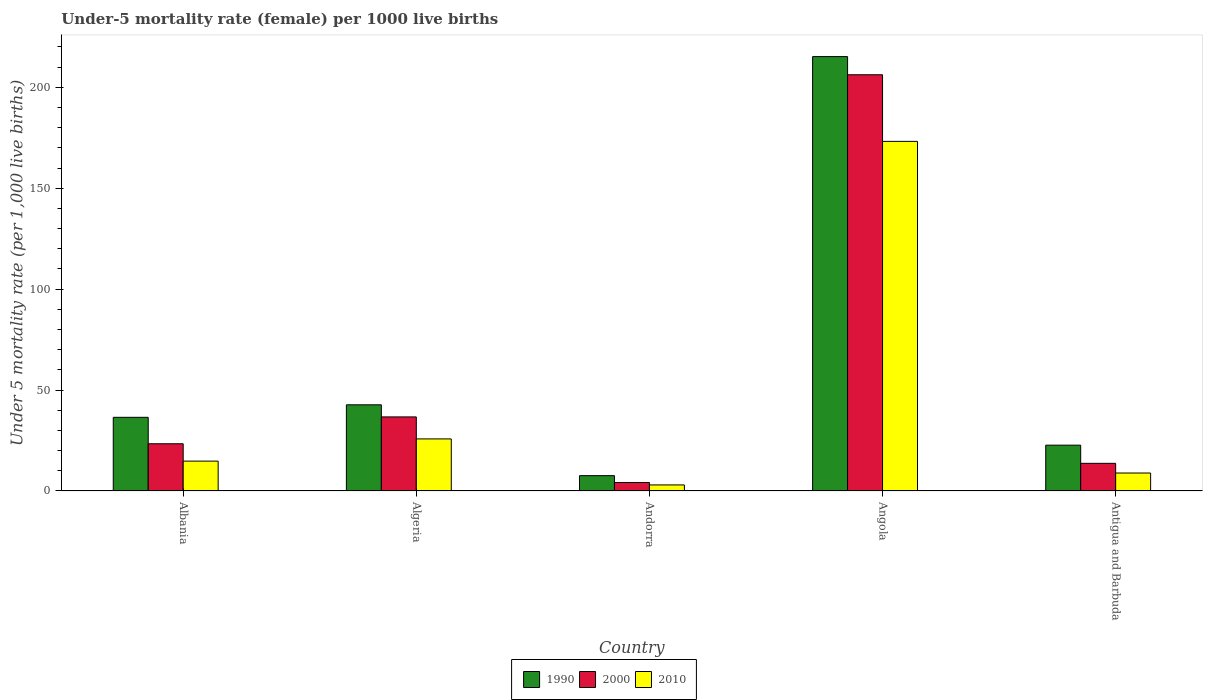How many different coloured bars are there?
Your response must be concise. 3. Are the number of bars on each tick of the X-axis equal?
Make the answer very short. Yes. What is the label of the 3rd group of bars from the left?
Offer a terse response. Andorra. In how many cases, is the number of bars for a given country not equal to the number of legend labels?
Offer a terse response. 0. What is the under-five mortality rate in 1990 in Angola?
Give a very brief answer. 215.2. Across all countries, what is the maximum under-five mortality rate in 2000?
Your answer should be compact. 206.2. In which country was the under-five mortality rate in 2000 maximum?
Provide a short and direct response. Angola. In which country was the under-five mortality rate in 2000 minimum?
Give a very brief answer. Andorra. What is the total under-five mortality rate in 1990 in the graph?
Your response must be concise. 324.7. What is the difference between the under-five mortality rate in 2010 in Algeria and that in Angola?
Make the answer very short. -147.4. What is the difference between the under-five mortality rate in 2000 in Antigua and Barbuda and the under-five mortality rate in 2010 in Albania?
Keep it short and to the point. -1.1. What is the average under-five mortality rate in 1990 per country?
Provide a succinct answer. 64.94. What is the difference between the under-five mortality rate of/in 2010 and under-five mortality rate of/in 1990 in Andorra?
Your answer should be compact. -4.6. In how many countries, is the under-five mortality rate in 2000 greater than 40?
Offer a very short reply. 1. What is the ratio of the under-five mortality rate in 2010 in Albania to that in Angola?
Give a very brief answer. 0.09. What is the difference between the highest and the second highest under-five mortality rate in 2000?
Ensure brevity in your answer.  -169.5. What is the difference between the highest and the lowest under-five mortality rate in 2010?
Your answer should be compact. 170.2. Is the sum of the under-five mortality rate in 2010 in Algeria and Antigua and Barbuda greater than the maximum under-five mortality rate in 2000 across all countries?
Ensure brevity in your answer.  No. What does the 3rd bar from the left in Angola represents?
Your answer should be very brief. 2010. Is it the case that in every country, the sum of the under-five mortality rate in 2010 and under-five mortality rate in 1990 is greater than the under-five mortality rate in 2000?
Your answer should be compact. Yes. How many bars are there?
Offer a very short reply. 15. Are all the bars in the graph horizontal?
Your answer should be very brief. No. Are the values on the major ticks of Y-axis written in scientific E-notation?
Provide a short and direct response. No. Does the graph contain grids?
Make the answer very short. No. Where does the legend appear in the graph?
Offer a terse response. Bottom center. How many legend labels are there?
Provide a short and direct response. 3. How are the legend labels stacked?
Offer a terse response. Horizontal. What is the title of the graph?
Provide a short and direct response. Under-5 mortality rate (female) per 1000 live births. What is the label or title of the Y-axis?
Offer a terse response. Under 5 mortality rate (per 1,0 live births). What is the Under 5 mortality rate (per 1,000 live births) of 1990 in Albania?
Your answer should be compact. 36.5. What is the Under 5 mortality rate (per 1,000 live births) in 2000 in Albania?
Make the answer very short. 23.4. What is the Under 5 mortality rate (per 1,000 live births) of 1990 in Algeria?
Give a very brief answer. 42.7. What is the Under 5 mortality rate (per 1,000 live births) in 2000 in Algeria?
Make the answer very short. 36.7. What is the Under 5 mortality rate (per 1,000 live births) in 2010 in Algeria?
Keep it short and to the point. 25.8. What is the Under 5 mortality rate (per 1,000 live births) in 1990 in Andorra?
Offer a very short reply. 7.6. What is the Under 5 mortality rate (per 1,000 live births) of 2000 in Andorra?
Provide a short and direct response. 4.2. What is the Under 5 mortality rate (per 1,000 live births) in 2010 in Andorra?
Keep it short and to the point. 3. What is the Under 5 mortality rate (per 1,000 live births) of 1990 in Angola?
Give a very brief answer. 215.2. What is the Under 5 mortality rate (per 1,000 live births) in 2000 in Angola?
Your response must be concise. 206.2. What is the Under 5 mortality rate (per 1,000 live births) of 2010 in Angola?
Your response must be concise. 173.2. What is the Under 5 mortality rate (per 1,000 live births) in 1990 in Antigua and Barbuda?
Provide a short and direct response. 22.7. Across all countries, what is the maximum Under 5 mortality rate (per 1,000 live births) in 1990?
Your answer should be very brief. 215.2. Across all countries, what is the maximum Under 5 mortality rate (per 1,000 live births) in 2000?
Ensure brevity in your answer.  206.2. Across all countries, what is the maximum Under 5 mortality rate (per 1,000 live births) of 2010?
Give a very brief answer. 173.2. Across all countries, what is the minimum Under 5 mortality rate (per 1,000 live births) in 1990?
Provide a succinct answer. 7.6. What is the total Under 5 mortality rate (per 1,000 live births) in 1990 in the graph?
Your answer should be very brief. 324.7. What is the total Under 5 mortality rate (per 1,000 live births) in 2000 in the graph?
Your answer should be very brief. 284.2. What is the total Under 5 mortality rate (per 1,000 live births) of 2010 in the graph?
Your response must be concise. 225.7. What is the difference between the Under 5 mortality rate (per 1,000 live births) in 1990 in Albania and that in Algeria?
Keep it short and to the point. -6.2. What is the difference between the Under 5 mortality rate (per 1,000 live births) of 1990 in Albania and that in Andorra?
Offer a very short reply. 28.9. What is the difference between the Under 5 mortality rate (per 1,000 live births) of 2000 in Albania and that in Andorra?
Provide a succinct answer. 19.2. What is the difference between the Under 5 mortality rate (per 1,000 live births) of 1990 in Albania and that in Angola?
Your answer should be very brief. -178.7. What is the difference between the Under 5 mortality rate (per 1,000 live births) in 2000 in Albania and that in Angola?
Give a very brief answer. -182.8. What is the difference between the Under 5 mortality rate (per 1,000 live births) of 2010 in Albania and that in Angola?
Ensure brevity in your answer.  -158.4. What is the difference between the Under 5 mortality rate (per 1,000 live births) of 1990 in Albania and that in Antigua and Barbuda?
Give a very brief answer. 13.8. What is the difference between the Under 5 mortality rate (per 1,000 live births) of 2000 in Albania and that in Antigua and Barbuda?
Ensure brevity in your answer.  9.7. What is the difference between the Under 5 mortality rate (per 1,000 live births) of 2010 in Albania and that in Antigua and Barbuda?
Give a very brief answer. 5.9. What is the difference between the Under 5 mortality rate (per 1,000 live births) in 1990 in Algeria and that in Andorra?
Offer a terse response. 35.1. What is the difference between the Under 5 mortality rate (per 1,000 live births) of 2000 in Algeria and that in Andorra?
Ensure brevity in your answer.  32.5. What is the difference between the Under 5 mortality rate (per 1,000 live births) in 2010 in Algeria and that in Andorra?
Keep it short and to the point. 22.8. What is the difference between the Under 5 mortality rate (per 1,000 live births) of 1990 in Algeria and that in Angola?
Make the answer very short. -172.5. What is the difference between the Under 5 mortality rate (per 1,000 live births) of 2000 in Algeria and that in Angola?
Your answer should be very brief. -169.5. What is the difference between the Under 5 mortality rate (per 1,000 live births) of 2010 in Algeria and that in Angola?
Provide a short and direct response. -147.4. What is the difference between the Under 5 mortality rate (per 1,000 live births) of 1990 in Algeria and that in Antigua and Barbuda?
Your answer should be compact. 20. What is the difference between the Under 5 mortality rate (per 1,000 live births) in 2000 in Algeria and that in Antigua and Barbuda?
Your answer should be compact. 23. What is the difference between the Under 5 mortality rate (per 1,000 live births) in 2010 in Algeria and that in Antigua and Barbuda?
Offer a terse response. 16.9. What is the difference between the Under 5 mortality rate (per 1,000 live births) in 1990 in Andorra and that in Angola?
Your answer should be compact. -207.6. What is the difference between the Under 5 mortality rate (per 1,000 live births) in 2000 in Andorra and that in Angola?
Ensure brevity in your answer.  -202. What is the difference between the Under 5 mortality rate (per 1,000 live births) in 2010 in Andorra and that in Angola?
Your response must be concise. -170.2. What is the difference between the Under 5 mortality rate (per 1,000 live births) of 1990 in Andorra and that in Antigua and Barbuda?
Make the answer very short. -15.1. What is the difference between the Under 5 mortality rate (per 1,000 live births) of 1990 in Angola and that in Antigua and Barbuda?
Provide a short and direct response. 192.5. What is the difference between the Under 5 mortality rate (per 1,000 live births) of 2000 in Angola and that in Antigua and Barbuda?
Offer a terse response. 192.5. What is the difference between the Under 5 mortality rate (per 1,000 live births) in 2010 in Angola and that in Antigua and Barbuda?
Keep it short and to the point. 164.3. What is the difference between the Under 5 mortality rate (per 1,000 live births) of 1990 in Albania and the Under 5 mortality rate (per 1,000 live births) of 2000 in Algeria?
Keep it short and to the point. -0.2. What is the difference between the Under 5 mortality rate (per 1,000 live births) in 2000 in Albania and the Under 5 mortality rate (per 1,000 live births) in 2010 in Algeria?
Provide a short and direct response. -2.4. What is the difference between the Under 5 mortality rate (per 1,000 live births) in 1990 in Albania and the Under 5 mortality rate (per 1,000 live births) in 2000 in Andorra?
Keep it short and to the point. 32.3. What is the difference between the Under 5 mortality rate (per 1,000 live births) in 1990 in Albania and the Under 5 mortality rate (per 1,000 live births) in 2010 in Andorra?
Make the answer very short. 33.5. What is the difference between the Under 5 mortality rate (per 1,000 live births) in 2000 in Albania and the Under 5 mortality rate (per 1,000 live births) in 2010 in Andorra?
Keep it short and to the point. 20.4. What is the difference between the Under 5 mortality rate (per 1,000 live births) in 1990 in Albania and the Under 5 mortality rate (per 1,000 live births) in 2000 in Angola?
Make the answer very short. -169.7. What is the difference between the Under 5 mortality rate (per 1,000 live births) in 1990 in Albania and the Under 5 mortality rate (per 1,000 live births) in 2010 in Angola?
Your answer should be compact. -136.7. What is the difference between the Under 5 mortality rate (per 1,000 live births) of 2000 in Albania and the Under 5 mortality rate (per 1,000 live births) of 2010 in Angola?
Keep it short and to the point. -149.8. What is the difference between the Under 5 mortality rate (per 1,000 live births) of 1990 in Albania and the Under 5 mortality rate (per 1,000 live births) of 2000 in Antigua and Barbuda?
Provide a succinct answer. 22.8. What is the difference between the Under 5 mortality rate (per 1,000 live births) in 1990 in Albania and the Under 5 mortality rate (per 1,000 live births) in 2010 in Antigua and Barbuda?
Your answer should be compact. 27.6. What is the difference between the Under 5 mortality rate (per 1,000 live births) in 2000 in Albania and the Under 5 mortality rate (per 1,000 live births) in 2010 in Antigua and Barbuda?
Your response must be concise. 14.5. What is the difference between the Under 5 mortality rate (per 1,000 live births) in 1990 in Algeria and the Under 5 mortality rate (per 1,000 live births) in 2000 in Andorra?
Your response must be concise. 38.5. What is the difference between the Under 5 mortality rate (per 1,000 live births) of 1990 in Algeria and the Under 5 mortality rate (per 1,000 live births) of 2010 in Andorra?
Offer a very short reply. 39.7. What is the difference between the Under 5 mortality rate (per 1,000 live births) of 2000 in Algeria and the Under 5 mortality rate (per 1,000 live births) of 2010 in Andorra?
Provide a succinct answer. 33.7. What is the difference between the Under 5 mortality rate (per 1,000 live births) of 1990 in Algeria and the Under 5 mortality rate (per 1,000 live births) of 2000 in Angola?
Your response must be concise. -163.5. What is the difference between the Under 5 mortality rate (per 1,000 live births) in 1990 in Algeria and the Under 5 mortality rate (per 1,000 live births) in 2010 in Angola?
Your answer should be compact. -130.5. What is the difference between the Under 5 mortality rate (per 1,000 live births) in 2000 in Algeria and the Under 5 mortality rate (per 1,000 live births) in 2010 in Angola?
Your response must be concise. -136.5. What is the difference between the Under 5 mortality rate (per 1,000 live births) of 1990 in Algeria and the Under 5 mortality rate (per 1,000 live births) of 2000 in Antigua and Barbuda?
Your answer should be very brief. 29. What is the difference between the Under 5 mortality rate (per 1,000 live births) in 1990 in Algeria and the Under 5 mortality rate (per 1,000 live births) in 2010 in Antigua and Barbuda?
Offer a very short reply. 33.8. What is the difference between the Under 5 mortality rate (per 1,000 live births) in 2000 in Algeria and the Under 5 mortality rate (per 1,000 live births) in 2010 in Antigua and Barbuda?
Ensure brevity in your answer.  27.8. What is the difference between the Under 5 mortality rate (per 1,000 live births) in 1990 in Andorra and the Under 5 mortality rate (per 1,000 live births) in 2000 in Angola?
Your answer should be very brief. -198.6. What is the difference between the Under 5 mortality rate (per 1,000 live births) in 1990 in Andorra and the Under 5 mortality rate (per 1,000 live births) in 2010 in Angola?
Your answer should be compact. -165.6. What is the difference between the Under 5 mortality rate (per 1,000 live births) in 2000 in Andorra and the Under 5 mortality rate (per 1,000 live births) in 2010 in Angola?
Offer a very short reply. -169. What is the difference between the Under 5 mortality rate (per 1,000 live births) of 1990 in Andorra and the Under 5 mortality rate (per 1,000 live births) of 2010 in Antigua and Barbuda?
Your response must be concise. -1.3. What is the difference between the Under 5 mortality rate (per 1,000 live births) of 2000 in Andorra and the Under 5 mortality rate (per 1,000 live births) of 2010 in Antigua and Barbuda?
Provide a short and direct response. -4.7. What is the difference between the Under 5 mortality rate (per 1,000 live births) in 1990 in Angola and the Under 5 mortality rate (per 1,000 live births) in 2000 in Antigua and Barbuda?
Ensure brevity in your answer.  201.5. What is the difference between the Under 5 mortality rate (per 1,000 live births) of 1990 in Angola and the Under 5 mortality rate (per 1,000 live births) of 2010 in Antigua and Barbuda?
Give a very brief answer. 206.3. What is the difference between the Under 5 mortality rate (per 1,000 live births) in 2000 in Angola and the Under 5 mortality rate (per 1,000 live births) in 2010 in Antigua and Barbuda?
Make the answer very short. 197.3. What is the average Under 5 mortality rate (per 1,000 live births) of 1990 per country?
Offer a terse response. 64.94. What is the average Under 5 mortality rate (per 1,000 live births) in 2000 per country?
Give a very brief answer. 56.84. What is the average Under 5 mortality rate (per 1,000 live births) of 2010 per country?
Your response must be concise. 45.14. What is the difference between the Under 5 mortality rate (per 1,000 live births) of 1990 and Under 5 mortality rate (per 1,000 live births) of 2010 in Albania?
Provide a succinct answer. 21.7. What is the difference between the Under 5 mortality rate (per 1,000 live births) of 2000 and Under 5 mortality rate (per 1,000 live births) of 2010 in Albania?
Your answer should be compact. 8.6. What is the difference between the Under 5 mortality rate (per 1,000 live births) of 1990 and Under 5 mortality rate (per 1,000 live births) of 2000 in Algeria?
Ensure brevity in your answer.  6. What is the difference between the Under 5 mortality rate (per 1,000 live births) of 1990 and Under 5 mortality rate (per 1,000 live births) of 2010 in Algeria?
Your response must be concise. 16.9. What is the difference between the Under 5 mortality rate (per 1,000 live births) in 1990 and Under 5 mortality rate (per 1,000 live births) in 2010 in Andorra?
Provide a short and direct response. 4.6. What is the difference between the Under 5 mortality rate (per 1,000 live births) of 1990 and Under 5 mortality rate (per 1,000 live births) of 2000 in Antigua and Barbuda?
Ensure brevity in your answer.  9. What is the difference between the Under 5 mortality rate (per 1,000 live births) of 1990 and Under 5 mortality rate (per 1,000 live births) of 2010 in Antigua and Barbuda?
Keep it short and to the point. 13.8. What is the ratio of the Under 5 mortality rate (per 1,000 live births) in 1990 in Albania to that in Algeria?
Ensure brevity in your answer.  0.85. What is the ratio of the Under 5 mortality rate (per 1,000 live births) in 2000 in Albania to that in Algeria?
Your response must be concise. 0.64. What is the ratio of the Under 5 mortality rate (per 1,000 live births) in 2010 in Albania to that in Algeria?
Provide a succinct answer. 0.57. What is the ratio of the Under 5 mortality rate (per 1,000 live births) in 1990 in Albania to that in Andorra?
Your answer should be very brief. 4.8. What is the ratio of the Under 5 mortality rate (per 1,000 live births) of 2000 in Albania to that in Andorra?
Provide a succinct answer. 5.57. What is the ratio of the Under 5 mortality rate (per 1,000 live births) in 2010 in Albania to that in Andorra?
Provide a short and direct response. 4.93. What is the ratio of the Under 5 mortality rate (per 1,000 live births) of 1990 in Albania to that in Angola?
Offer a very short reply. 0.17. What is the ratio of the Under 5 mortality rate (per 1,000 live births) of 2000 in Albania to that in Angola?
Provide a short and direct response. 0.11. What is the ratio of the Under 5 mortality rate (per 1,000 live births) in 2010 in Albania to that in Angola?
Your response must be concise. 0.09. What is the ratio of the Under 5 mortality rate (per 1,000 live births) in 1990 in Albania to that in Antigua and Barbuda?
Your answer should be very brief. 1.61. What is the ratio of the Under 5 mortality rate (per 1,000 live births) in 2000 in Albania to that in Antigua and Barbuda?
Your answer should be very brief. 1.71. What is the ratio of the Under 5 mortality rate (per 1,000 live births) in 2010 in Albania to that in Antigua and Barbuda?
Provide a short and direct response. 1.66. What is the ratio of the Under 5 mortality rate (per 1,000 live births) of 1990 in Algeria to that in Andorra?
Offer a very short reply. 5.62. What is the ratio of the Under 5 mortality rate (per 1,000 live births) of 2000 in Algeria to that in Andorra?
Your answer should be compact. 8.74. What is the ratio of the Under 5 mortality rate (per 1,000 live births) in 2010 in Algeria to that in Andorra?
Keep it short and to the point. 8.6. What is the ratio of the Under 5 mortality rate (per 1,000 live births) of 1990 in Algeria to that in Angola?
Offer a terse response. 0.2. What is the ratio of the Under 5 mortality rate (per 1,000 live births) in 2000 in Algeria to that in Angola?
Your response must be concise. 0.18. What is the ratio of the Under 5 mortality rate (per 1,000 live births) in 2010 in Algeria to that in Angola?
Ensure brevity in your answer.  0.15. What is the ratio of the Under 5 mortality rate (per 1,000 live births) in 1990 in Algeria to that in Antigua and Barbuda?
Make the answer very short. 1.88. What is the ratio of the Under 5 mortality rate (per 1,000 live births) in 2000 in Algeria to that in Antigua and Barbuda?
Offer a terse response. 2.68. What is the ratio of the Under 5 mortality rate (per 1,000 live births) of 2010 in Algeria to that in Antigua and Barbuda?
Make the answer very short. 2.9. What is the ratio of the Under 5 mortality rate (per 1,000 live births) in 1990 in Andorra to that in Angola?
Your answer should be very brief. 0.04. What is the ratio of the Under 5 mortality rate (per 1,000 live births) in 2000 in Andorra to that in Angola?
Your response must be concise. 0.02. What is the ratio of the Under 5 mortality rate (per 1,000 live births) of 2010 in Andorra to that in Angola?
Your answer should be very brief. 0.02. What is the ratio of the Under 5 mortality rate (per 1,000 live births) of 1990 in Andorra to that in Antigua and Barbuda?
Offer a terse response. 0.33. What is the ratio of the Under 5 mortality rate (per 1,000 live births) of 2000 in Andorra to that in Antigua and Barbuda?
Your answer should be compact. 0.31. What is the ratio of the Under 5 mortality rate (per 1,000 live births) of 2010 in Andorra to that in Antigua and Barbuda?
Your response must be concise. 0.34. What is the ratio of the Under 5 mortality rate (per 1,000 live births) of 1990 in Angola to that in Antigua and Barbuda?
Provide a succinct answer. 9.48. What is the ratio of the Under 5 mortality rate (per 1,000 live births) in 2000 in Angola to that in Antigua and Barbuda?
Offer a very short reply. 15.05. What is the ratio of the Under 5 mortality rate (per 1,000 live births) of 2010 in Angola to that in Antigua and Barbuda?
Keep it short and to the point. 19.46. What is the difference between the highest and the second highest Under 5 mortality rate (per 1,000 live births) of 1990?
Keep it short and to the point. 172.5. What is the difference between the highest and the second highest Under 5 mortality rate (per 1,000 live births) of 2000?
Your answer should be compact. 169.5. What is the difference between the highest and the second highest Under 5 mortality rate (per 1,000 live births) of 2010?
Provide a succinct answer. 147.4. What is the difference between the highest and the lowest Under 5 mortality rate (per 1,000 live births) in 1990?
Provide a short and direct response. 207.6. What is the difference between the highest and the lowest Under 5 mortality rate (per 1,000 live births) in 2000?
Provide a short and direct response. 202. What is the difference between the highest and the lowest Under 5 mortality rate (per 1,000 live births) in 2010?
Your answer should be compact. 170.2. 